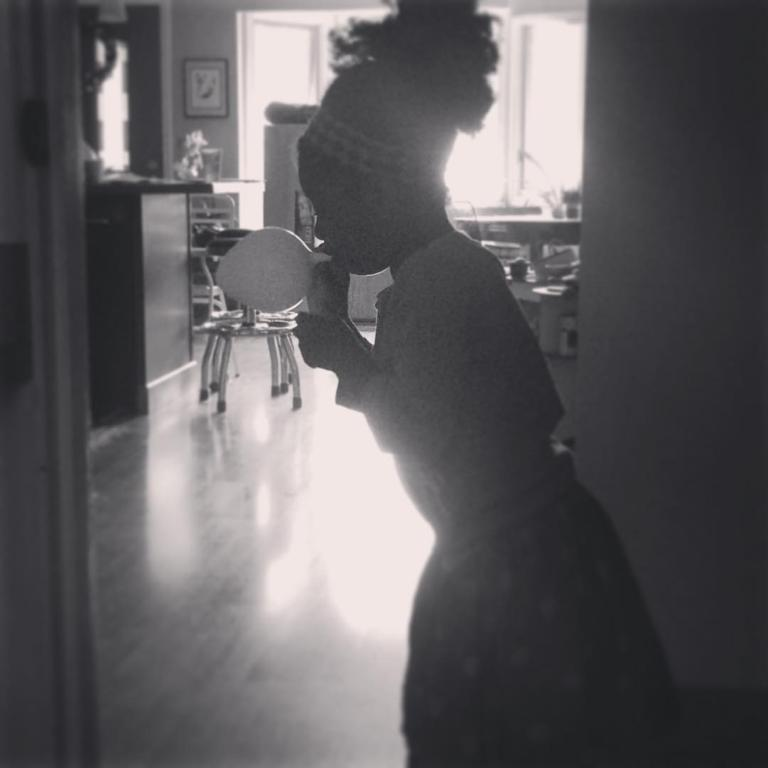Who is present in the image? There is a woman in the image. What is the woman doing in the image? The woman is standing and blowing a balloon. What furniture can be seen in the image? There is a chair and a desk in the image. Are there any objects on the desk? The provided facts do not specify any objects on the desk. What is on the wall in the image? There is a frame on the wall. What type of trade is being conducted in the image? There is no indication of any trade being conducted in the image; it features a woman blowing a balloon. Can you see any sand in the image? There is no sand present in the image. 